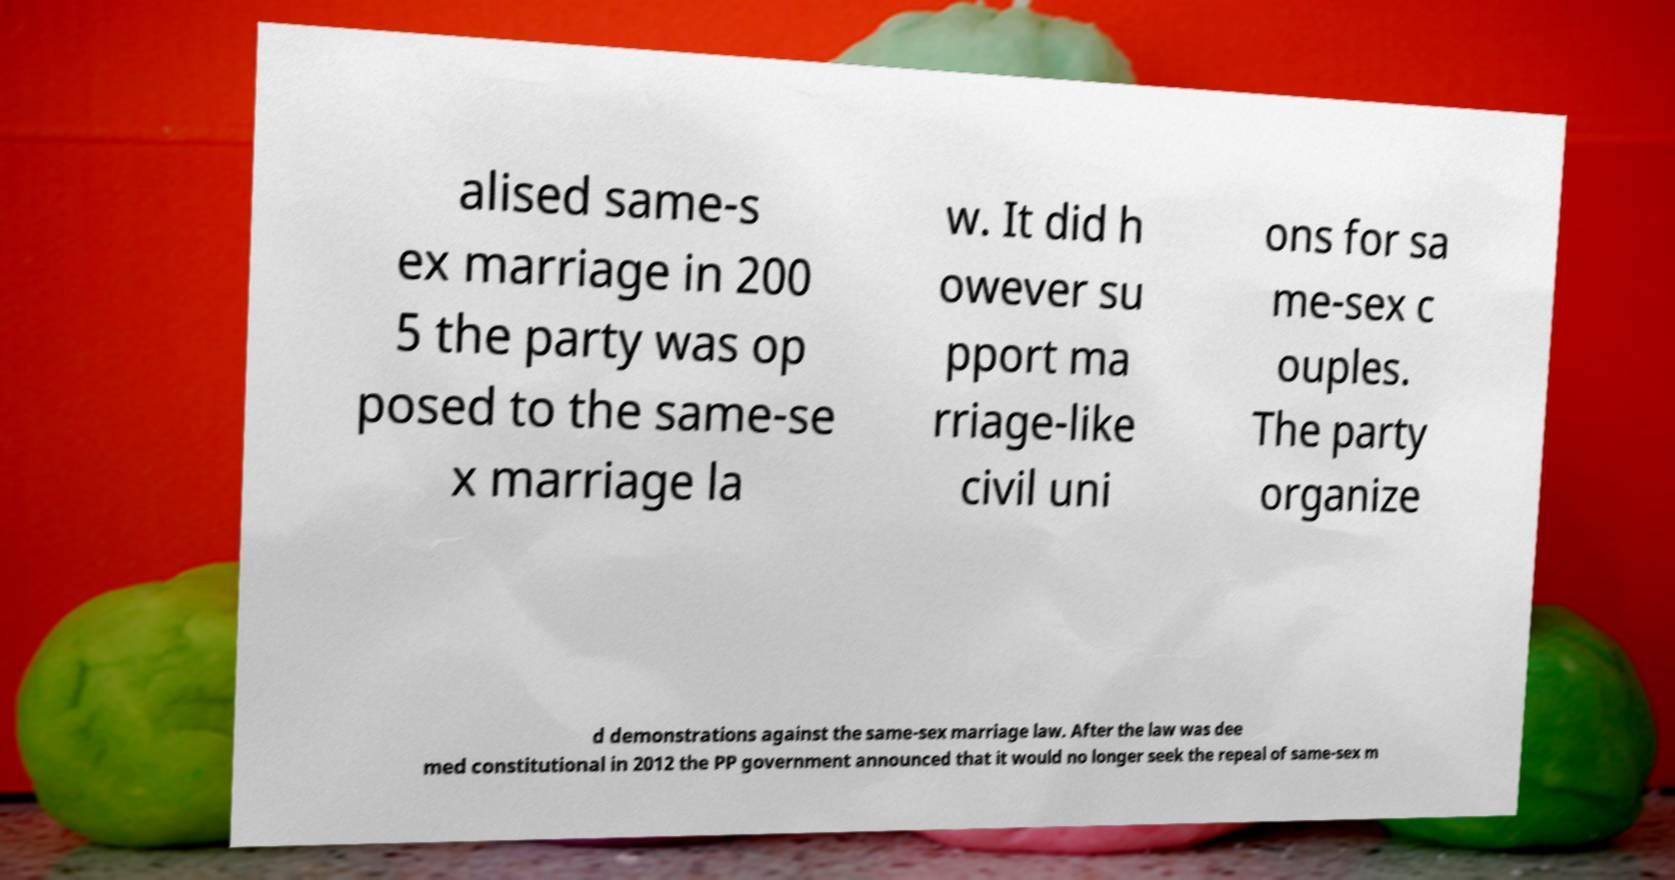What messages or text are displayed in this image? I need them in a readable, typed format. alised same-s ex marriage in 200 5 the party was op posed to the same-se x marriage la w. It did h owever su pport ma rriage-like civil uni ons for sa me-sex c ouples. The party organize d demonstrations against the same-sex marriage law. After the law was dee med constitutional in 2012 the PP government announced that it would no longer seek the repeal of same-sex m 